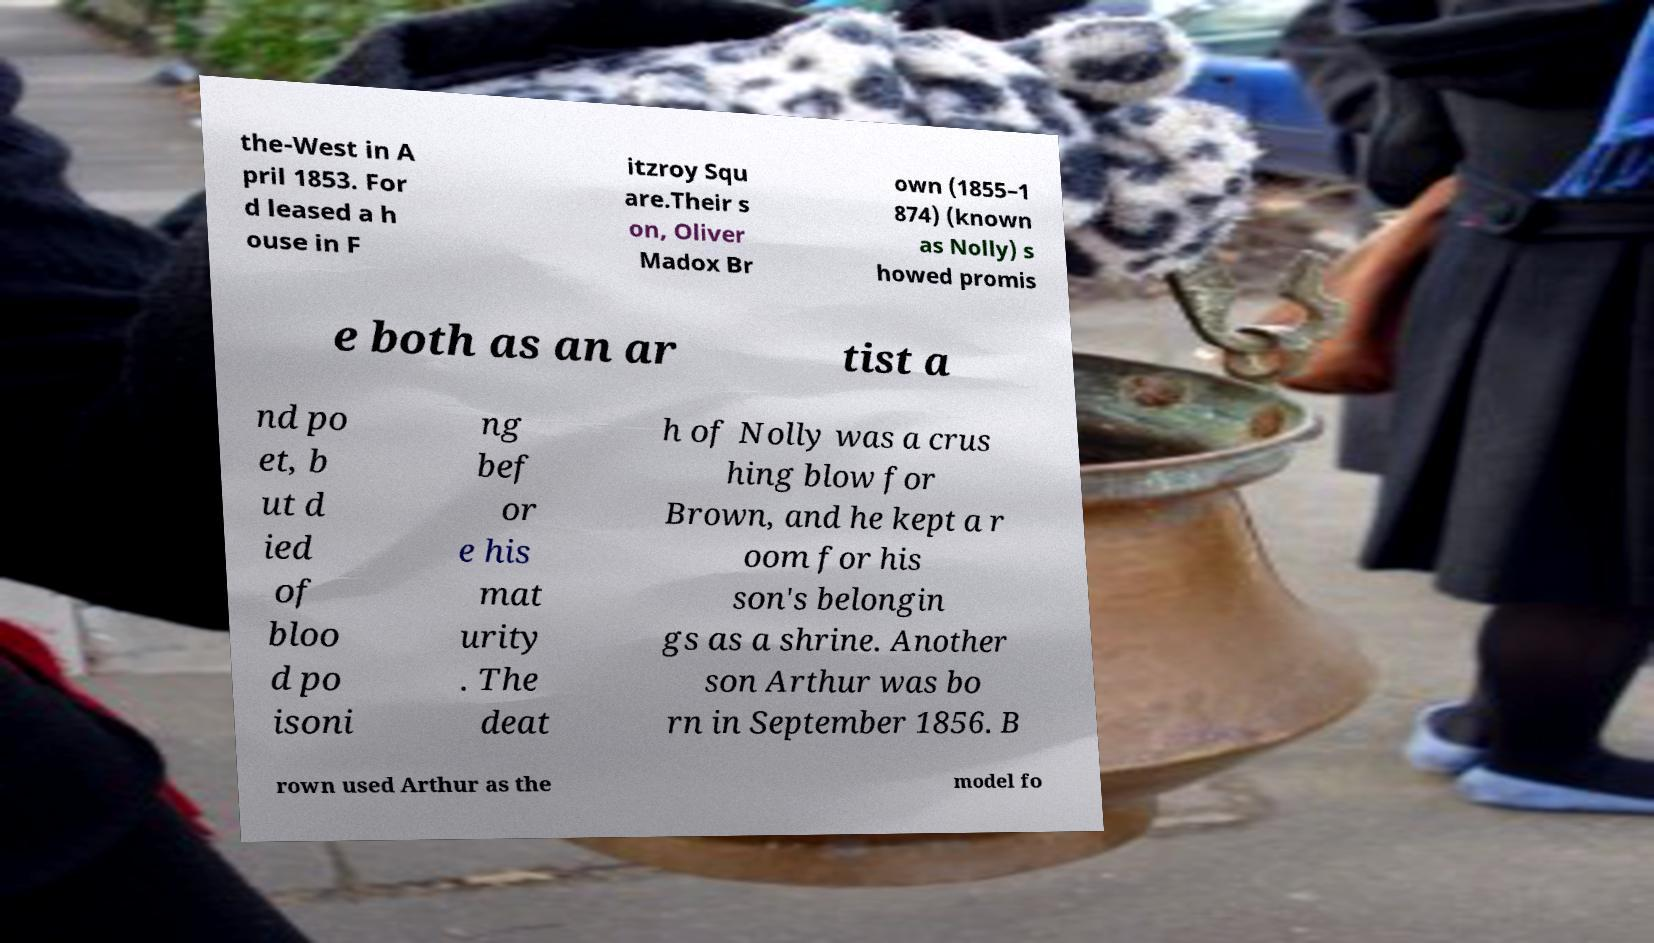For documentation purposes, I need the text within this image transcribed. Could you provide that? the-West in A pril 1853. For d leased a h ouse in F itzroy Squ are.Their s on, Oliver Madox Br own (1855–1 874) (known as Nolly) s howed promis e both as an ar tist a nd po et, b ut d ied of bloo d po isoni ng bef or e his mat urity . The deat h of Nolly was a crus hing blow for Brown, and he kept a r oom for his son's belongin gs as a shrine. Another son Arthur was bo rn in September 1856. B rown used Arthur as the model fo 